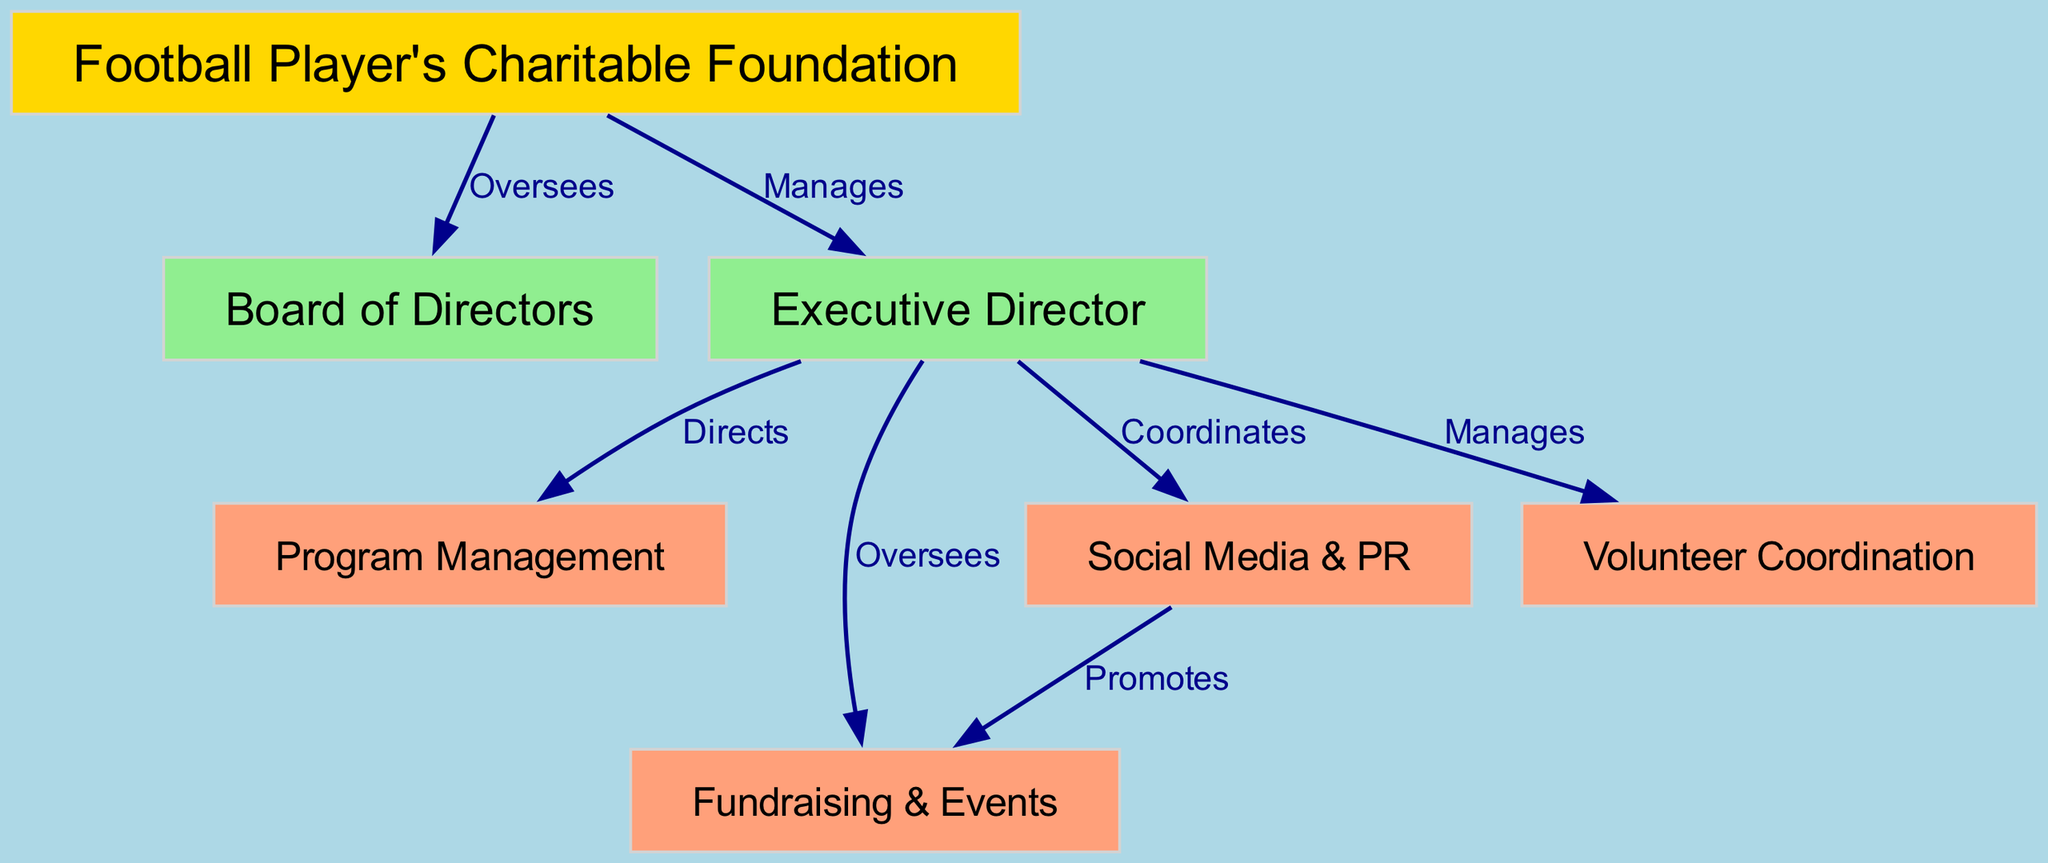What is the highest level in the organizational structure? The highest level is the Football Player's Charitable Foundation. This is evident as it is the root node of the diagram and oversees all other components within it.
Answer: Football Player's Charitable Foundation How many nodes are present in the diagram? Counting all the nodes listed in the data: Football Player's Charitable Foundation, Board of Directors, Executive Director, Program Management, Fundraising & Events, Social Media & PR, and Volunteer Coordination, gives a total of seven distinct nodes.
Answer: 7 Which node does the Executive Director directly manage? The Executive Director directly manages Program Management, Fundraising & Events, Social Media & PR, and Volunteer Coordination. This can be seen from multiple outgoing edges from the Executive Director to these respective nodes indicating management responsibility.
Answer: Program Management, Fundraising & Events, Social Media & PR, Volunteer Coordination What is the relationship between the Board of Directors and the Football Player's Charitable Foundation? The diagram indicates that the Board of Directors "Oversees" the Football Player's Charitable Foundation. This is shown by the edge labeled "Oversees" connecting the two nodes.
Answer: Oversees Which department's activities are promoted by Social Media & PR? The Social Media & PR department promotes the activities of Fundraising & Events, as indicated by the edge labeled "Promotes" between the Social Media & PR node and the Fundraising & Events node.
Answer: Fundraising & Events Is there any node that the Executive Director does not have a direct connection to? Yes, the Board of Directors is the only node that does not have a direct connection to the Executive Director. The flow from the Executive Director goes only to other operational nodes and not to the governance node.
Answer: Yes What role does the Executive Director play in the organization? The Executive Director plays a pivotal management role by directing Program Management and coordinating with Social Media & PR while overseeing Fundraising & Events and managing Volunteer Coordination. This indicates their central role in both operational and strategic oversight in the foundation.
Answer: Manages and Coordinates How many edges connect to the Executive Director? The Executive Director has four edges connecting to it, which indicates the departments it manages and oversees. This is tallied by examining all direct relationships that originate from the Executive Director.
Answer: 4 